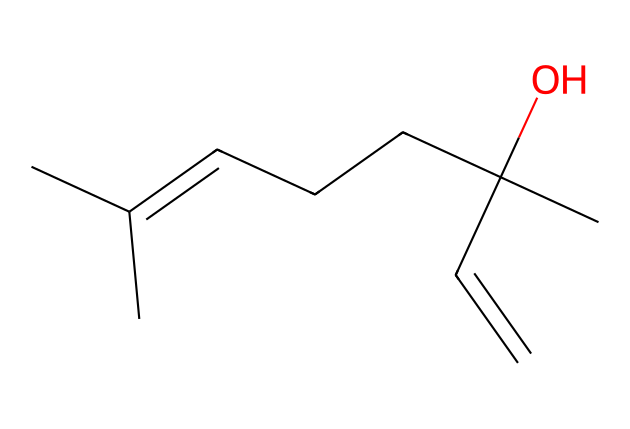What is the number of carbon atoms in this molecule? In the provided SMILES representation, we can count the carbon atoms (C). The lettering 'C' indicates carbon, and by counting, we find that there are 10 carbon atoms in total in the molecule.
Answer: 10 How many double bonds are present in this chemical structure? The SMILES shows 'C=C', which indicates the presence of a double bond. Upon inspection, there is only one instance of a double bond in the molecular structure.
Answer: 1 What functional group is indicated by the "(O)" in the SMILES? The "(O)" in the SMILES represents an alcohol functional group, which is characterized by the presence of a hydroxyl group (-OH). This is what signifies the molecule as having alcohol properties.
Answer: alcohol Is this molecule more likely to be polar or nonpolar? The presence of the alcohol functional group (the -OH group) suggests that the molecule has polar characteristics due to the electronegativity of the oxygen atom attracting electrons, which leads to polar covalent bonding.
Answer: polar What type of chemical compound does this structure represent? The presence of multiple carbon atoms and an alcohol functional group indicates that this compound is likely to be a type of hydrocarbon, specifically an alcohol, classified under organic compounds.
Answer: alcohol 